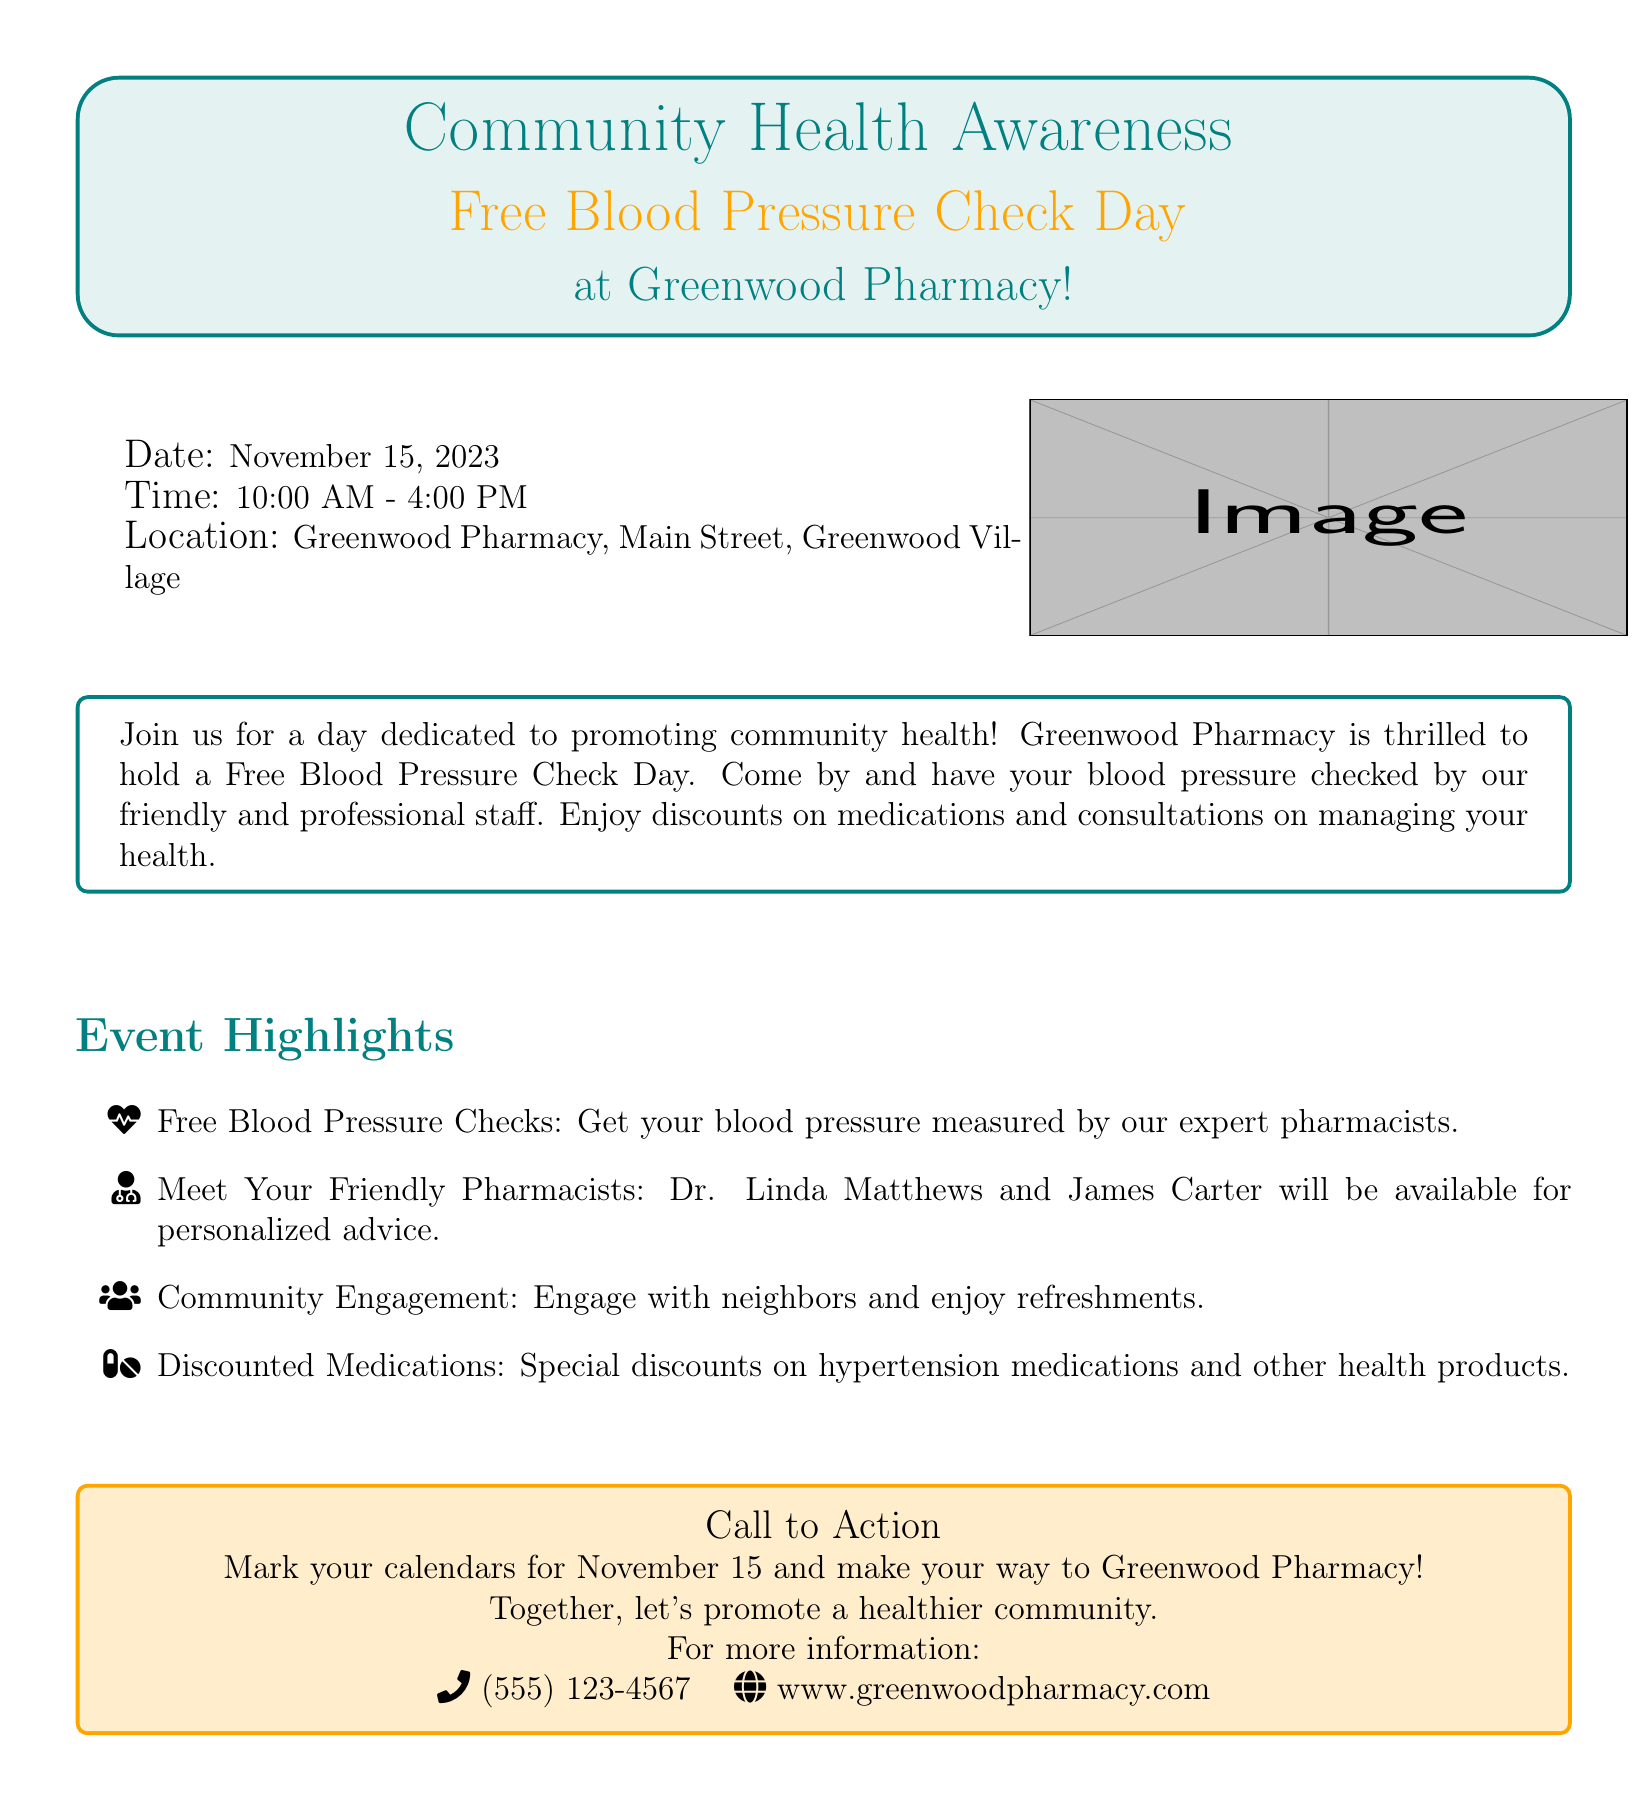What is the date of the event? The date of the Free Blood Pressure Check Day is explicitly stated in the document.
Answer: November 15, 2023 What are the operating hours for the event? The time for the event is provided in the document, specifying when it begins and ends.
Answer: 10:00 AM - 4:00 PM Where is the event taking place? The location of the event is mentioned clearly in the advertisement.
Answer: Greenwood Pharmacy, Main Street, Greenwood Village Who will be available for personalized advice? The document lists the names of the pharmacists who will be present during the event.
Answer: Dr. Linda Matthews and James Carter What health service is being offered for free? The key service promoted in the event is stated in the title of the advertisement.
Answer: Blood pressure checks What is included in the community engagement? The advertisement mentions activities that promote interaction among attendees.
Answer: Refreshments What kind of discounts can participants expect? The document specifies types of products that will be discounted during the event.
Answer: Hypertension medications and other health products What is the call to action in the announcement? The document includes a specific prompt encouraging attendance at the event.
Answer: Mark your calendars for November 15 and make your way to Greenwood Pharmacy 